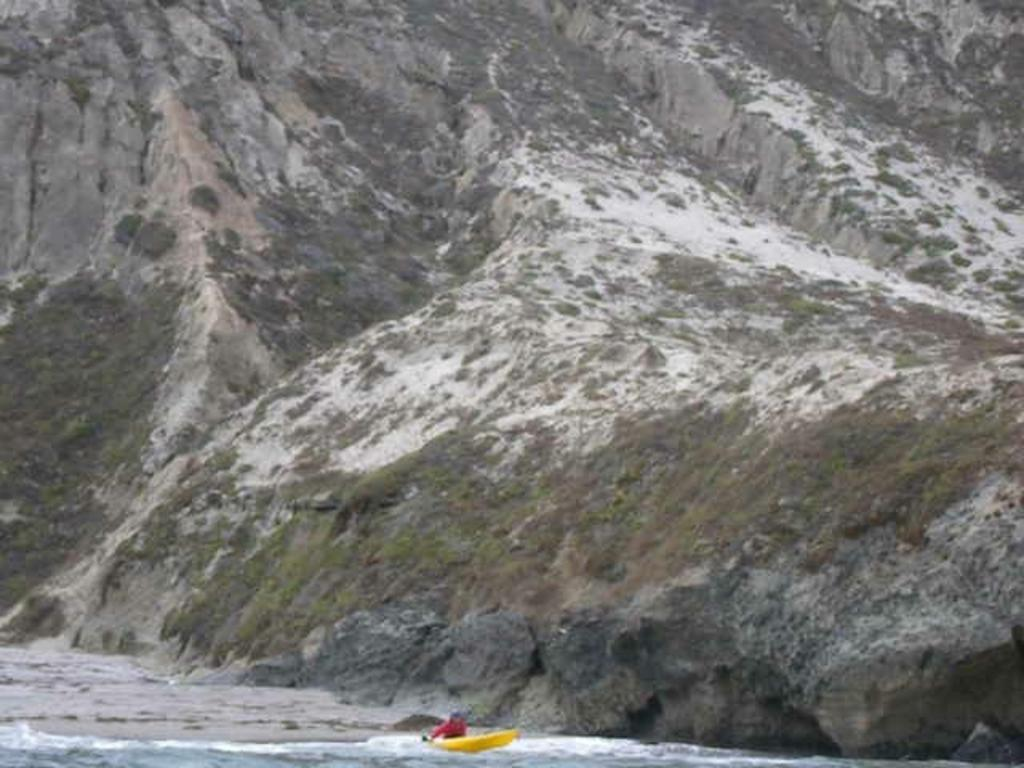Who or what is in the image? There is a person in the image. What is the person doing in the image? The person is sitting in a yellow boat. What is the boat floating on? The boat is floating on water. What can be seen in the distance in the image? There are mountains visible in the background of the image. What type of needle is being used by the person in the image? There is no needle present in the image; the person is sitting in a yellow boat floating on water. 